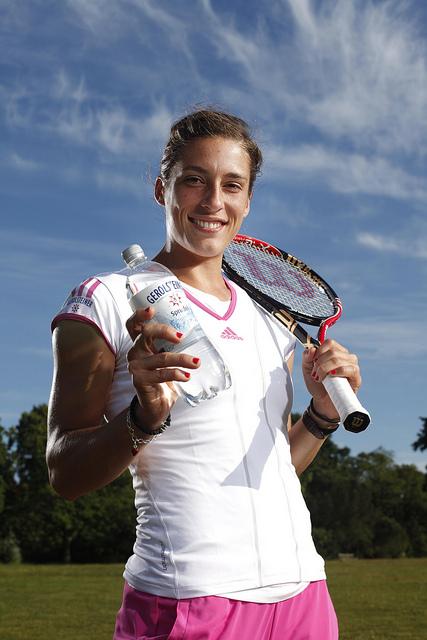What color is the woman's shorts?
Answer briefly. Pink. What brand of water is that?
Keep it brief. Gerolsteiner. What brand of racquet is the woman holding?
Answer briefly. Wilson. 